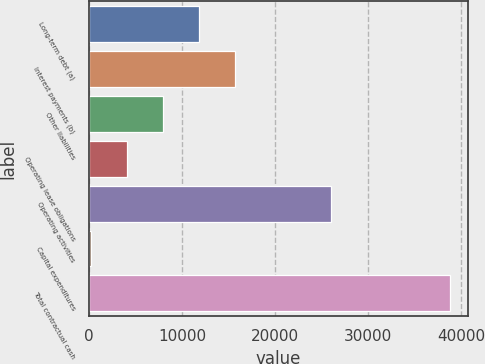Convert chart. <chart><loc_0><loc_0><loc_500><loc_500><bar_chart><fcel>Long-term debt (a)<fcel>Interest payments (b)<fcel>Other liabilities<fcel>Operating lease obligations<fcel>Operating activities<fcel>Capital expenditures<fcel>Total contractual cash<nl><fcel>11818.9<fcel>15673.2<fcel>7964.6<fcel>4110.3<fcel>26051<fcel>256<fcel>38799<nl></chart> 